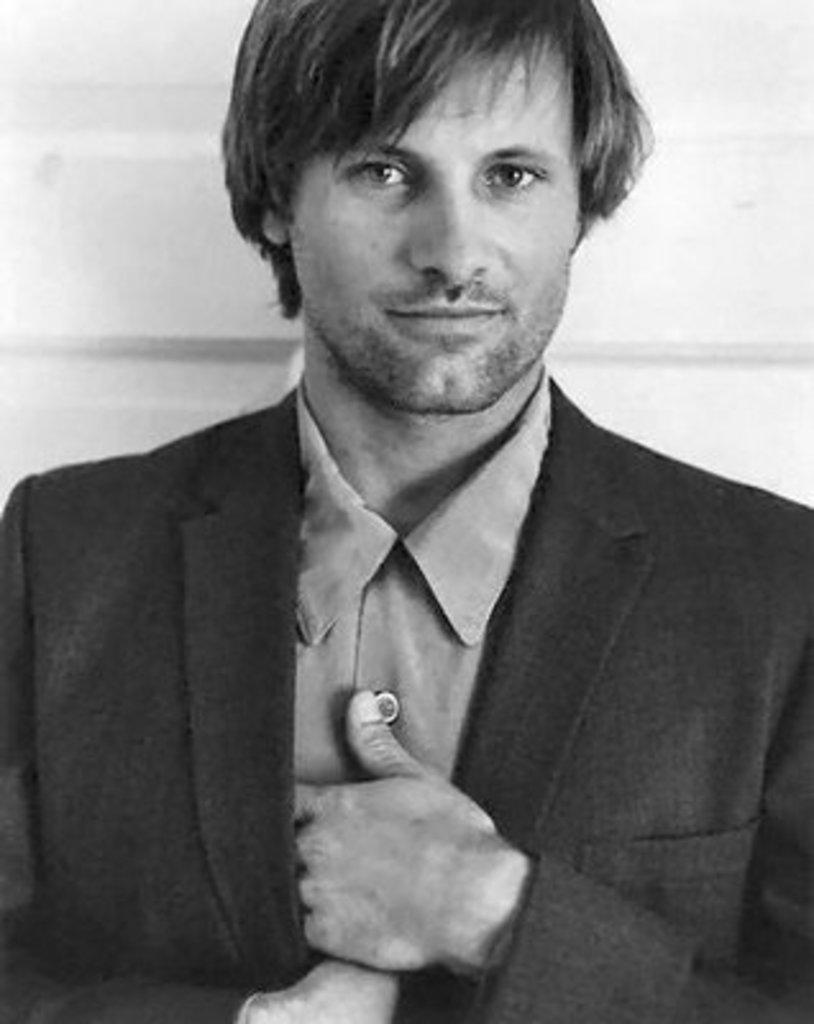Can you describe this image briefly? It is a black and white image. In this picture, we can see a person is watching. 